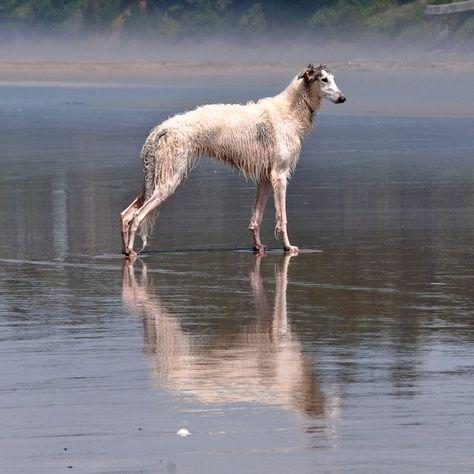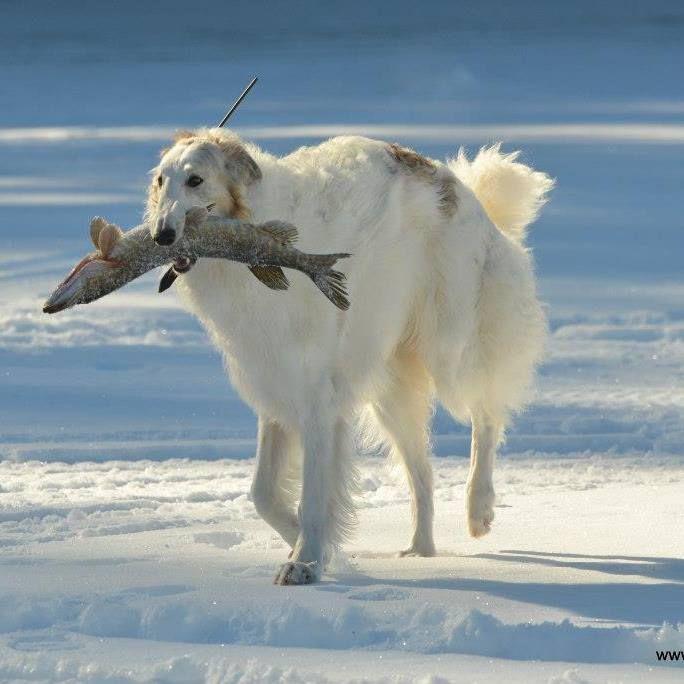The first image is the image on the left, the second image is the image on the right. Examine the images to the left and right. Is the description "There are more than two dogs present." accurate? Answer yes or no. No. The first image is the image on the left, the second image is the image on the right. Examine the images to the left and right. Is the description "There is only one dog in both pictures" accurate? Answer yes or no. Yes. 